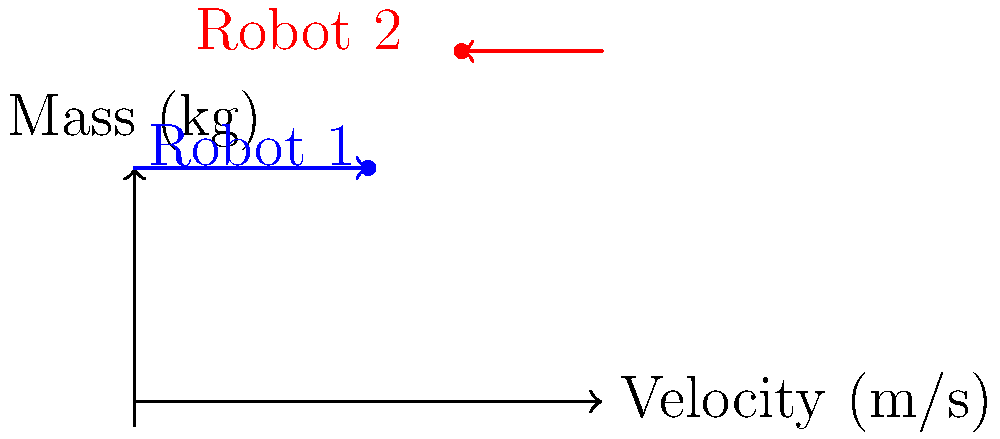In a BattleBots match, Robot 1 (mass 100 kg) is moving at 5 m/s to the right, while Robot 2 (mass 150 kg) is moving at 3 m/s to the left. If they collide head-on and stick together, what will be their final velocity immediately after the collision? Assume the collision is perfectly inelastic. To solve this problem, we'll use the principle of conservation of momentum, as the collision is perfectly inelastic (the robots stick together after collision).

Step 1: Calculate the initial momentum of each robot.
Robot 1: $p_1 = m_1v_1 = 100 \text{ kg} \times 5 \text{ m/s} = 500 \text{ kg}\cdot\text{m/s}$
Robot 2: $p_2 = m_2v_2 = 150 \text{ kg} \times (-3 \text{ m/s}) = -450 \text{ kg}\cdot\text{m/s}$

Step 2: Calculate the total initial momentum of the system.
$p_{total} = p_1 + p_2 = 500 \text{ kg}\cdot\text{m/s} + (-450 \text{ kg}\cdot\text{m/s}) = 50 \text{ kg}\cdot\text{m/s}$

Step 3: Use conservation of momentum to find the final velocity.
Initial momentum = Final momentum
$p_{total} = (m_1 + m_2)v_f$
$50 \text{ kg}\cdot\text{m/s} = (100 \text{ kg} + 150 \text{ kg})v_f$
$50 \text{ kg}\cdot\text{m/s} = 250 \text{ kg} \times v_f$

Step 4: Solve for the final velocity.
$v_f = \frac{50 \text{ kg}\cdot\text{m/s}}{250 \text{ kg}} = 0.2 \text{ m/s}$

The positive value indicates that the combined robots will move to the right after the collision.
Answer: 0.2 m/s to the right 